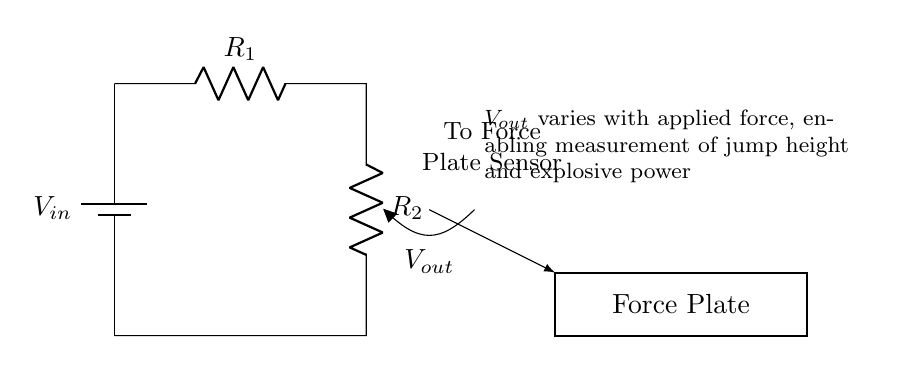What is the input voltage in this circuit? The input voltage is indicated as V_in in the circuit diagram, typically represented by the battery symbol on the left side of the circuit.
Answer: V_in What do the resistors R_1 and R_2 represent? R_1 and R_2 are the two resistors in the voltage divider circuit. They are used to divide the input voltage into a smaller output voltage.
Answer: Resistors What is the output voltage related to in this circuit? The output voltage V_out is the voltage across the output terminals, which varies when force is applied to the force plate, allowing for measurement of jump height and explosive power.
Answer: Force How does the output voltage change with applied force? The output voltage V_out decreases as the applied force increases due to the voltage divider principle, where the voltage across a resistor in a series circuit is proportional to its resistance.
Answer: Decreases Why is this circuit type specifically useful in a force plate sensor? This voltage divider circuit is useful because it allows for precise measurement of varying forces by generating a different V_out corresponding to the applied force, facilitating analysis of jump height and explosive power.
Answer: Measurement If R_1 is 10k ohms and R_2 is 5k ohms, what would be the ratio of output voltage to input voltage? The output voltage to input voltage ratio of a voltage divider is given by the formula R_2 / (R_1 + R_2). Plugging in the values 5k/(10k + 5k) gives 1/3.
Answer: One third 